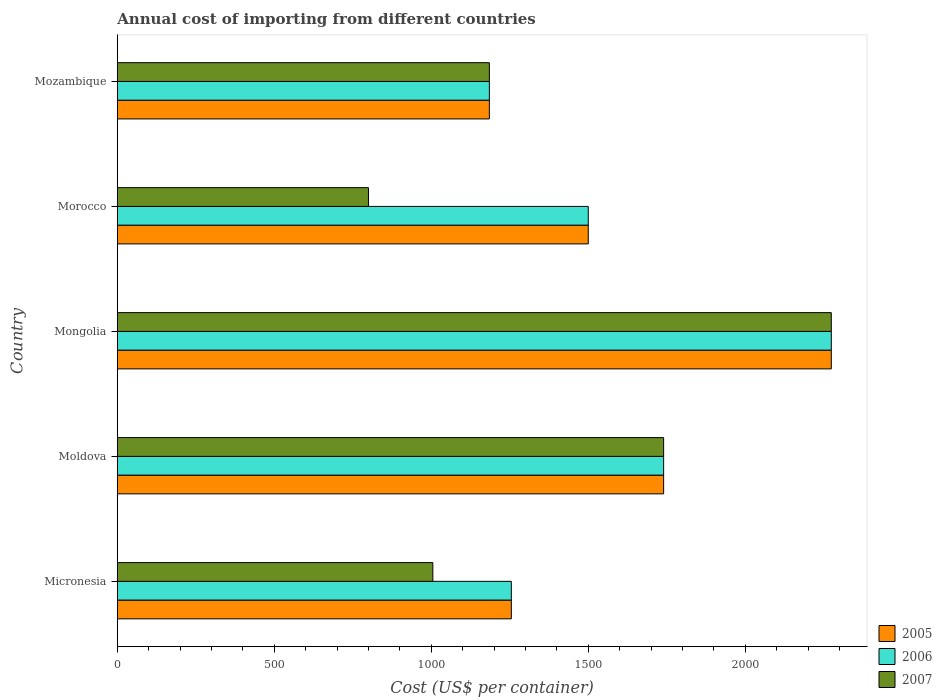How many groups of bars are there?
Make the answer very short. 5. How many bars are there on the 5th tick from the bottom?
Your answer should be very brief. 3. What is the label of the 1st group of bars from the top?
Your answer should be compact. Mozambique. What is the total annual cost of importing in 2007 in Morocco?
Your answer should be compact. 800. Across all countries, what is the maximum total annual cost of importing in 2006?
Provide a short and direct response. 2274. Across all countries, what is the minimum total annual cost of importing in 2006?
Give a very brief answer. 1185. In which country was the total annual cost of importing in 2006 maximum?
Ensure brevity in your answer.  Mongolia. In which country was the total annual cost of importing in 2007 minimum?
Offer a very short reply. Morocco. What is the total total annual cost of importing in 2006 in the graph?
Provide a short and direct response. 7954. What is the difference between the total annual cost of importing in 2007 in Moldova and that in Morocco?
Provide a succinct answer. 940. What is the difference between the total annual cost of importing in 2006 in Mongolia and the total annual cost of importing in 2007 in Micronesia?
Your answer should be very brief. 1269. What is the average total annual cost of importing in 2005 per country?
Give a very brief answer. 1590.8. What is the difference between the total annual cost of importing in 2007 and total annual cost of importing in 2005 in Micronesia?
Offer a very short reply. -250. In how many countries, is the total annual cost of importing in 2005 greater than 400 US$?
Your response must be concise. 5. What is the ratio of the total annual cost of importing in 2005 in Micronesia to that in Mongolia?
Keep it short and to the point. 0.55. What is the difference between the highest and the second highest total annual cost of importing in 2005?
Your answer should be compact. 534. What is the difference between the highest and the lowest total annual cost of importing in 2006?
Provide a succinct answer. 1089. In how many countries, is the total annual cost of importing in 2007 greater than the average total annual cost of importing in 2007 taken over all countries?
Your response must be concise. 2. What does the 3rd bar from the bottom in Micronesia represents?
Give a very brief answer. 2007. Are all the bars in the graph horizontal?
Your answer should be compact. Yes. How many countries are there in the graph?
Give a very brief answer. 5. Does the graph contain any zero values?
Provide a short and direct response. No. How many legend labels are there?
Make the answer very short. 3. What is the title of the graph?
Make the answer very short. Annual cost of importing from different countries. Does "1975" appear as one of the legend labels in the graph?
Ensure brevity in your answer.  No. What is the label or title of the X-axis?
Provide a succinct answer. Cost (US$ per container). What is the Cost (US$ per container) of 2005 in Micronesia?
Your answer should be compact. 1255. What is the Cost (US$ per container) of 2006 in Micronesia?
Give a very brief answer. 1255. What is the Cost (US$ per container) of 2007 in Micronesia?
Provide a short and direct response. 1005. What is the Cost (US$ per container) of 2005 in Moldova?
Your answer should be very brief. 1740. What is the Cost (US$ per container) in 2006 in Moldova?
Offer a terse response. 1740. What is the Cost (US$ per container) in 2007 in Moldova?
Ensure brevity in your answer.  1740. What is the Cost (US$ per container) of 2005 in Mongolia?
Offer a very short reply. 2274. What is the Cost (US$ per container) in 2006 in Mongolia?
Your response must be concise. 2274. What is the Cost (US$ per container) of 2007 in Mongolia?
Your answer should be very brief. 2274. What is the Cost (US$ per container) of 2005 in Morocco?
Offer a terse response. 1500. What is the Cost (US$ per container) in 2006 in Morocco?
Give a very brief answer. 1500. What is the Cost (US$ per container) in 2007 in Morocco?
Give a very brief answer. 800. What is the Cost (US$ per container) in 2005 in Mozambique?
Your answer should be compact. 1185. What is the Cost (US$ per container) in 2006 in Mozambique?
Provide a succinct answer. 1185. What is the Cost (US$ per container) of 2007 in Mozambique?
Ensure brevity in your answer.  1185. Across all countries, what is the maximum Cost (US$ per container) of 2005?
Ensure brevity in your answer.  2274. Across all countries, what is the maximum Cost (US$ per container) in 2006?
Provide a succinct answer. 2274. Across all countries, what is the maximum Cost (US$ per container) of 2007?
Your response must be concise. 2274. Across all countries, what is the minimum Cost (US$ per container) of 2005?
Provide a succinct answer. 1185. Across all countries, what is the minimum Cost (US$ per container) of 2006?
Offer a terse response. 1185. Across all countries, what is the minimum Cost (US$ per container) in 2007?
Provide a succinct answer. 800. What is the total Cost (US$ per container) of 2005 in the graph?
Ensure brevity in your answer.  7954. What is the total Cost (US$ per container) in 2006 in the graph?
Offer a very short reply. 7954. What is the total Cost (US$ per container) in 2007 in the graph?
Keep it short and to the point. 7004. What is the difference between the Cost (US$ per container) in 2005 in Micronesia and that in Moldova?
Keep it short and to the point. -485. What is the difference between the Cost (US$ per container) of 2006 in Micronesia and that in Moldova?
Provide a short and direct response. -485. What is the difference between the Cost (US$ per container) of 2007 in Micronesia and that in Moldova?
Provide a succinct answer. -735. What is the difference between the Cost (US$ per container) in 2005 in Micronesia and that in Mongolia?
Provide a short and direct response. -1019. What is the difference between the Cost (US$ per container) in 2006 in Micronesia and that in Mongolia?
Your answer should be very brief. -1019. What is the difference between the Cost (US$ per container) of 2007 in Micronesia and that in Mongolia?
Provide a short and direct response. -1269. What is the difference between the Cost (US$ per container) of 2005 in Micronesia and that in Morocco?
Offer a very short reply. -245. What is the difference between the Cost (US$ per container) in 2006 in Micronesia and that in Morocco?
Provide a short and direct response. -245. What is the difference between the Cost (US$ per container) of 2007 in Micronesia and that in Morocco?
Make the answer very short. 205. What is the difference between the Cost (US$ per container) in 2007 in Micronesia and that in Mozambique?
Offer a very short reply. -180. What is the difference between the Cost (US$ per container) in 2005 in Moldova and that in Mongolia?
Ensure brevity in your answer.  -534. What is the difference between the Cost (US$ per container) in 2006 in Moldova and that in Mongolia?
Your response must be concise. -534. What is the difference between the Cost (US$ per container) in 2007 in Moldova and that in Mongolia?
Ensure brevity in your answer.  -534. What is the difference between the Cost (US$ per container) of 2005 in Moldova and that in Morocco?
Your response must be concise. 240. What is the difference between the Cost (US$ per container) of 2006 in Moldova and that in Morocco?
Provide a short and direct response. 240. What is the difference between the Cost (US$ per container) in 2007 in Moldova and that in Morocco?
Offer a very short reply. 940. What is the difference between the Cost (US$ per container) in 2005 in Moldova and that in Mozambique?
Provide a short and direct response. 555. What is the difference between the Cost (US$ per container) in 2006 in Moldova and that in Mozambique?
Your answer should be very brief. 555. What is the difference between the Cost (US$ per container) in 2007 in Moldova and that in Mozambique?
Your answer should be compact. 555. What is the difference between the Cost (US$ per container) of 2005 in Mongolia and that in Morocco?
Your answer should be very brief. 774. What is the difference between the Cost (US$ per container) of 2006 in Mongolia and that in Morocco?
Your answer should be very brief. 774. What is the difference between the Cost (US$ per container) of 2007 in Mongolia and that in Morocco?
Your answer should be compact. 1474. What is the difference between the Cost (US$ per container) in 2005 in Mongolia and that in Mozambique?
Your response must be concise. 1089. What is the difference between the Cost (US$ per container) in 2006 in Mongolia and that in Mozambique?
Provide a succinct answer. 1089. What is the difference between the Cost (US$ per container) of 2007 in Mongolia and that in Mozambique?
Provide a short and direct response. 1089. What is the difference between the Cost (US$ per container) in 2005 in Morocco and that in Mozambique?
Provide a succinct answer. 315. What is the difference between the Cost (US$ per container) of 2006 in Morocco and that in Mozambique?
Ensure brevity in your answer.  315. What is the difference between the Cost (US$ per container) of 2007 in Morocco and that in Mozambique?
Offer a very short reply. -385. What is the difference between the Cost (US$ per container) in 2005 in Micronesia and the Cost (US$ per container) in 2006 in Moldova?
Offer a terse response. -485. What is the difference between the Cost (US$ per container) in 2005 in Micronesia and the Cost (US$ per container) in 2007 in Moldova?
Your response must be concise. -485. What is the difference between the Cost (US$ per container) of 2006 in Micronesia and the Cost (US$ per container) of 2007 in Moldova?
Your answer should be compact. -485. What is the difference between the Cost (US$ per container) in 2005 in Micronesia and the Cost (US$ per container) in 2006 in Mongolia?
Your response must be concise. -1019. What is the difference between the Cost (US$ per container) in 2005 in Micronesia and the Cost (US$ per container) in 2007 in Mongolia?
Ensure brevity in your answer.  -1019. What is the difference between the Cost (US$ per container) of 2006 in Micronesia and the Cost (US$ per container) of 2007 in Mongolia?
Offer a very short reply. -1019. What is the difference between the Cost (US$ per container) in 2005 in Micronesia and the Cost (US$ per container) in 2006 in Morocco?
Offer a terse response. -245. What is the difference between the Cost (US$ per container) in 2005 in Micronesia and the Cost (US$ per container) in 2007 in Morocco?
Keep it short and to the point. 455. What is the difference between the Cost (US$ per container) of 2006 in Micronesia and the Cost (US$ per container) of 2007 in Morocco?
Give a very brief answer. 455. What is the difference between the Cost (US$ per container) in 2005 in Micronesia and the Cost (US$ per container) in 2006 in Mozambique?
Your answer should be very brief. 70. What is the difference between the Cost (US$ per container) of 2005 in Micronesia and the Cost (US$ per container) of 2007 in Mozambique?
Make the answer very short. 70. What is the difference between the Cost (US$ per container) of 2005 in Moldova and the Cost (US$ per container) of 2006 in Mongolia?
Ensure brevity in your answer.  -534. What is the difference between the Cost (US$ per container) in 2005 in Moldova and the Cost (US$ per container) in 2007 in Mongolia?
Ensure brevity in your answer.  -534. What is the difference between the Cost (US$ per container) of 2006 in Moldova and the Cost (US$ per container) of 2007 in Mongolia?
Offer a very short reply. -534. What is the difference between the Cost (US$ per container) in 2005 in Moldova and the Cost (US$ per container) in 2006 in Morocco?
Your answer should be compact. 240. What is the difference between the Cost (US$ per container) in 2005 in Moldova and the Cost (US$ per container) in 2007 in Morocco?
Keep it short and to the point. 940. What is the difference between the Cost (US$ per container) of 2006 in Moldova and the Cost (US$ per container) of 2007 in Morocco?
Provide a short and direct response. 940. What is the difference between the Cost (US$ per container) of 2005 in Moldova and the Cost (US$ per container) of 2006 in Mozambique?
Your answer should be very brief. 555. What is the difference between the Cost (US$ per container) of 2005 in Moldova and the Cost (US$ per container) of 2007 in Mozambique?
Keep it short and to the point. 555. What is the difference between the Cost (US$ per container) of 2006 in Moldova and the Cost (US$ per container) of 2007 in Mozambique?
Keep it short and to the point. 555. What is the difference between the Cost (US$ per container) of 2005 in Mongolia and the Cost (US$ per container) of 2006 in Morocco?
Keep it short and to the point. 774. What is the difference between the Cost (US$ per container) in 2005 in Mongolia and the Cost (US$ per container) in 2007 in Morocco?
Keep it short and to the point. 1474. What is the difference between the Cost (US$ per container) in 2006 in Mongolia and the Cost (US$ per container) in 2007 in Morocco?
Offer a very short reply. 1474. What is the difference between the Cost (US$ per container) of 2005 in Mongolia and the Cost (US$ per container) of 2006 in Mozambique?
Provide a succinct answer. 1089. What is the difference between the Cost (US$ per container) of 2005 in Mongolia and the Cost (US$ per container) of 2007 in Mozambique?
Your answer should be very brief. 1089. What is the difference between the Cost (US$ per container) of 2006 in Mongolia and the Cost (US$ per container) of 2007 in Mozambique?
Make the answer very short. 1089. What is the difference between the Cost (US$ per container) of 2005 in Morocco and the Cost (US$ per container) of 2006 in Mozambique?
Provide a succinct answer. 315. What is the difference between the Cost (US$ per container) of 2005 in Morocco and the Cost (US$ per container) of 2007 in Mozambique?
Make the answer very short. 315. What is the difference between the Cost (US$ per container) of 2006 in Morocco and the Cost (US$ per container) of 2007 in Mozambique?
Offer a very short reply. 315. What is the average Cost (US$ per container) of 2005 per country?
Provide a short and direct response. 1590.8. What is the average Cost (US$ per container) in 2006 per country?
Your response must be concise. 1590.8. What is the average Cost (US$ per container) in 2007 per country?
Give a very brief answer. 1400.8. What is the difference between the Cost (US$ per container) in 2005 and Cost (US$ per container) in 2007 in Micronesia?
Provide a succinct answer. 250. What is the difference between the Cost (US$ per container) in 2006 and Cost (US$ per container) in 2007 in Micronesia?
Your answer should be compact. 250. What is the difference between the Cost (US$ per container) in 2005 and Cost (US$ per container) in 2006 in Moldova?
Keep it short and to the point. 0. What is the difference between the Cost (US$ per container) of 2005 and Cost (US$ per container) of 2007 in Mongolia?
Provide a succinct answer. 0. What is the difference between the Cost (US$ per container) in 2006 and Cost (US$ per container) in 2007 in Mongolia?
Provide a succinct answer. 0. What is the difference between the Cost (US$ per container) in 2005 and Cost (US$ per container) in 2006 in Morocco?
Provide a short and direct response. 0. What is the difference between the Cost (US$ per container) of 2005 and Cost (US$ per container) of 2007 in Morocco?
Your response must be concise. 700. What is the difference between the Cost (US$ per container) of 2006 and Cost (US$ per container) of 2007 in Morocco?
Provide a short and direct response. 700. What is the difference between the Cost (US$ per container) of 2005 and Cost (US$ per container) of 2006 in Mozambique?
Offer a very short reply. 0. What is the ratio of the Cost (US$ per container) of 2005 in Micronesia to that in Moldova?
Make the answer very short. 0.72. What is the ratio of the Cost (US$ per container) in 2006 in Micronesia to that in Moldova?
Ensure brevity in your answer.  0.72. What is the ratio of the Cost (US$ per container) of 2007 in Micronesia to that in Moldova?
Keep it short and to the point. 0.58. What is the ratio of the Cost (US$ per container) of 2005 in Micronesia to that in Mongolia?
Keep it short and to the point. 0.55. What is the ratio of the Cost (US$ per container) in 2006 in Micronesia to that in Mongolia?
Ensure brevity in your answer.  0.55. What is the ratio of the Cost (US$ per container) of 2007 in Micronesia to that in Mongolia?
Your response must be concise. 0.44. What is the ratio of the Cost (US$ per container) in 2005 in Micronesia to that in Morocco?
Provide a succinct answer. 0.84. What is the ratio of the Cost (US$ per container) of 2006 in Micronesia to that in Morocco?
Ensure brevity in your answer.  0.84. What is the ratio of the Cost (US$ per container) in 2007 in Micronesia to that in Morocco?
Offer a very short reply. 1.26. What is the ratio of the Cost (US$ per container) of 2005 in Micronesia to that in Mozambique?
Your answer should be very brief. 1.06. What is the ratio of the Cost (US$ per container) of 2006 in Micronesia to that in Mozambique?
Provide a succinct answer. 1.06. What is the ratio of the Cost (US$ per container) in 2007 in Micronesia to that in Mozambique?
Your response must be concise. 0.85. What is the ratio of the Cost (US$ per container) in 2005 in Moldova to that in Mongolia?
Your answer should be very brief. 0.77. What is the ratio of the Cost (US$ per container) of 2006 in Moldova to that in Mongolia?
Your answer should be compact. 0.77. What is the ratio of the Cost (US$ per container) of 2007 in Moldova to that in Mongolia?
Offer a very short reply. 0.77. What is the ratio of the Cost (US$ per container) in 2005 in Moldova to that in Morocco?
Offer a very short reply. 1.16. What is the ratio of the Cost (US$ per container) of 2006 in Moldova to that in Morocco?
Give a very brief answer. 1.16. What is the ratio of the Cost (US$ per container) in 2007 in Moldova to that in Morocco?
Give a very brief answer. 2.17. What is the ratio of the Cost (US$ per container) of 2005 in Moldova to that in Mozambique?
Offer a very short reply. 1.47. What is the ratio of the Cost (US$ per container) of 2006 in Moldova to that in Mozambique?
Your response must be concise. 1.47. What is the ratio of the Cost (US$ per container) in 2007 in Moldova to that in Mozambique?
Offer a very short reply. 1.47. What is the ratio of the Cost (US$ per container) in 2005 in Mongolia to that in Morocco?
Provide a succinct answer. 1.52. What is the ratio of the Cost (US$ per container) in 2006 in Mongolia to that in Morocco?
Provide a succinct answer. 1.52. What is the ratio of the Cost (US$ per container) in 2007 in Mongolia to that in Morocco?
Provide a succinct answer. 2.84. What is the ratio of the Cost (US$ per container) of 2005 in Mongolia to that in Mozambique?
Keep it short and to the point. 1.92. What is the ratio of the Cost (US$ per container) of 2006 in Mongolia to that in Mozambique?
Offer a terse response. 1.92. What is the ratio of the Cost (US$ per container) in 2007 in Mongolia to that in Mozambique?
Give a very brief answer. 1.92. What is the ratio of the Cost (US$ per container) of 2005 in Morocco to that in Mozambique?
Your answer should be compact. 1.27. What is the ratio of the Cost (US$ per container) in 2006 in Morocco to that in Mozambique?
Keep it short and to the point. 1.27. What is the ratio of the Cost (US$ per container) of 2007 in Morocco to that in Mozambique?
Your response must be concise. 0.68. What is the difference between the highest and the second highest Cost (US$ per container) in 2005?
Ensure brevity in your answer.  534. What is the difference between the highest and the second highest Cost (US$ per container) in 2006?
Provide a succinct answer. 534. What is the difference between the highest and the second highest Cost (US$ per container) in 2007?
Provide a short and direct response. 534. What is the difference between the highest and the lowest Cost (US$ per container) in 2005?
Make the answer very short. 1089. What is the difference between the highest and the lowest Cost (US$ per container) in 2006?
Your answer should be very brief. 1089. What is the difference between the highest and the lowest Cost (US$ per container) in 2007?
Make the answer very short. 1474. 